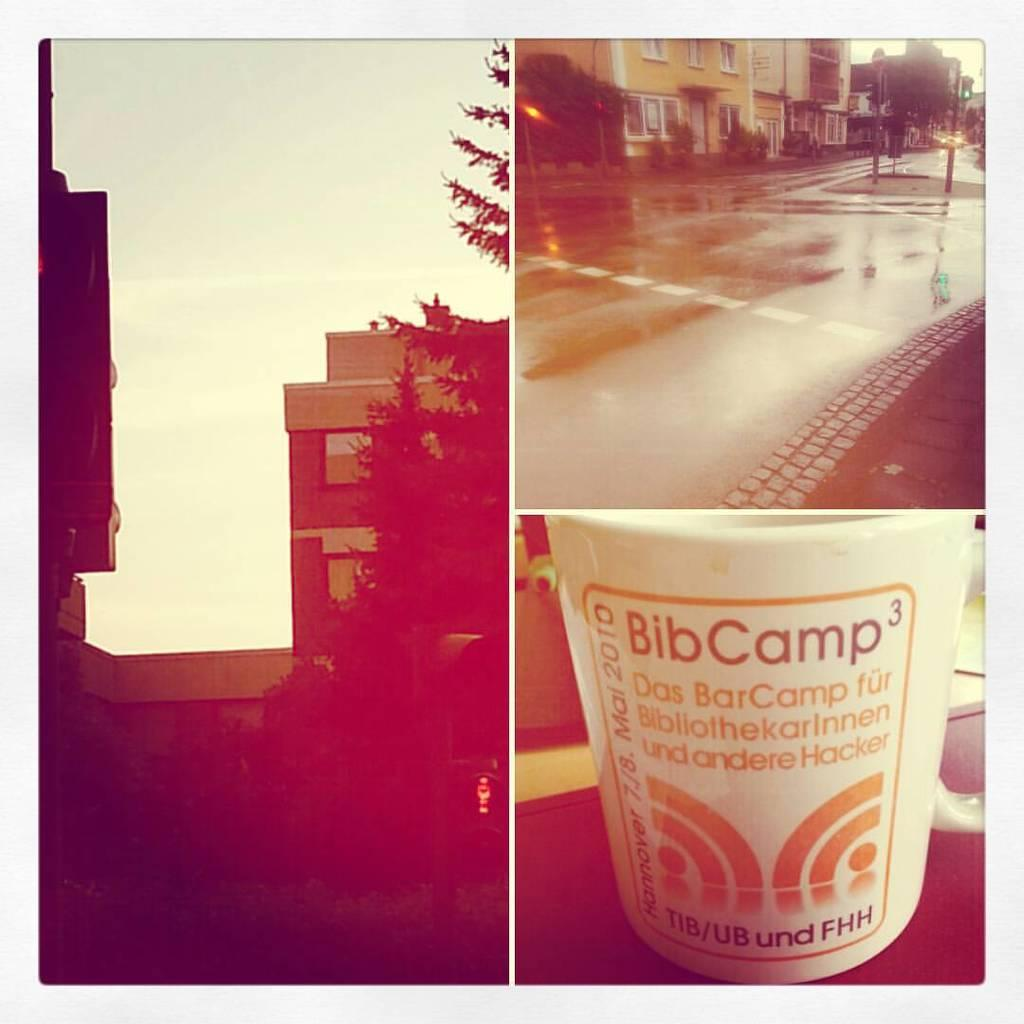Provide a one-sentence caption for the provided image. a Bib Camp container with a design on it. 